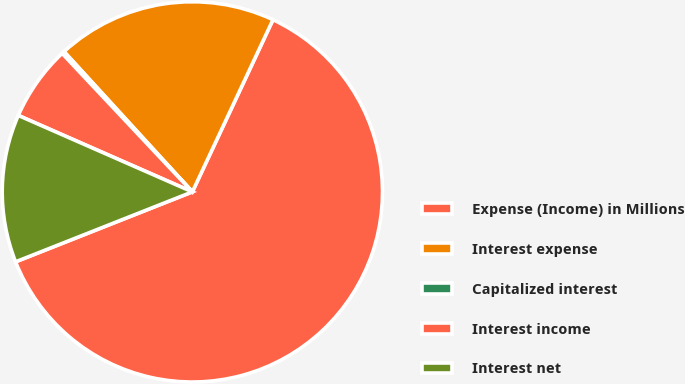Convert chart to OTSL. <chart><loc_0><loc_0><loc_500><loc_500><pie_chart><fcel>Expense (Income) in Millions<fcel>Interest expense<fcel>Capitalized interest<fcel>Interest income<fcel>Interest net<nl><fcel>62.03%<fcel>18.76%<fcel>0.22%<fcel>6.4%<fcel>12.58%<nl></chart> 